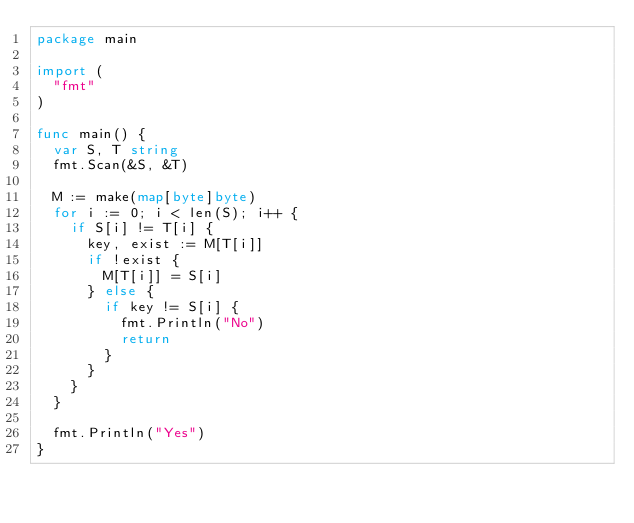Convert code to text. <code><loc_0><loc_0><loc_500><loc_500><_Go_>package main

import (
	"fmt"
)

func main() {
	var S, T string
	fmt.Scan(&S, &T)

	M := make(map[byte]byte)
	for i := 0; i < len(S); i++ {
		if S[i] != T[i] {
			key, exist := M[T[i]]
			if !exist {
				M[T[i]] = S[i]
			} else {
				if key != S[i] {
					fmt.Println("No")
					return
				}
			}
		}
	}

	fmt.Println("Yes")
}
</code> 